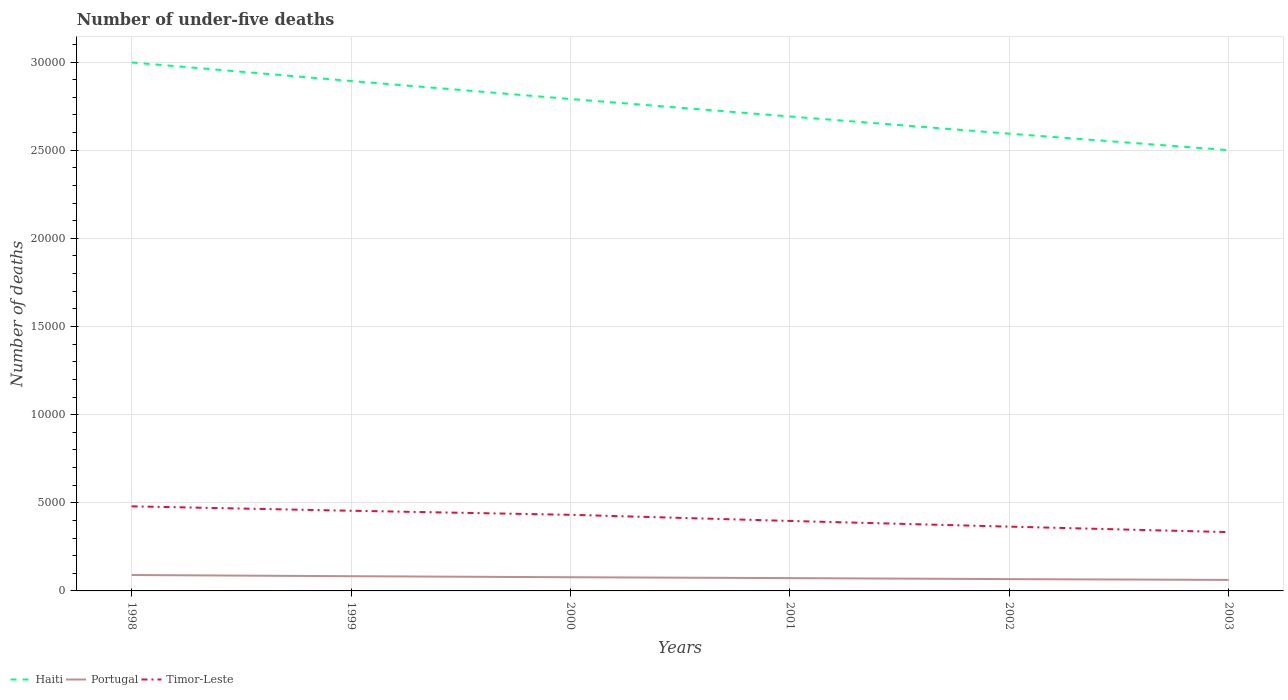How many different coloured lines are there?
Ensure brevity in your answer.  3. Does the line corresponding to Timor-Leste intersect with the line corresponding to Haiti?
Give a very brief answer. No. Across all years, what is the maximum number of under-five deaths in Timor-Leste?
Ensure brevity in your answer.  3336. What is the total number of under-five deaths in Haiti in the graph?
Make the answer very short. 4974. What is the difference between the highest and the second highest number of under-five deaths in Haiti?
Offer a terse response. 4974. What is the difference between the highest and the lowest number of under-five deaths in Haiti?
Offer a terse response. 3. How many lines are there?
Provide a succinct answer. 3. How many legend labels are there?
Give a very brief answer. 3. How are the legend labels stacked?
Give a very brief answer. Horizontal. What is the title of the graph?
Your answer should be very brief. Number of under-five deaths. Does "Kiribati" appear as one of the legend labels in the graph?
Make the answer very short. No. What is the label or title of the X-axis?
Your answer should be compact. Years. What is the label or title of the Y-axis?
Your answer should be very brief. Number of deaths. What is the Number of deaths of Haiti in 1998?
Give a very brief answer. 3.00e+04. What is the Number of deaths of Portugal in 1998?
Your response must be concise. 902. What is the Number of deaths of Timor-Leste in 1998?
Offer a terse response. 4799. What is the Number of deaths of Haiti in 1999?
Offer a terse response. 2.89e+04. What is the Number of deaths in Portugal in 1999?
Offer a very short reply. 835. What is the Number of deaths of Timor-Leste in 1999?
Keep it short and to the point. 4548. What is the Number of deaths of Haiti in 2000?
Keep it short and to the point. 2.79e+04. What is the Number of deaths in Portugal in 2000?
Your response must be concise. 776. What is the Number of deaths in Timor-Leste in 2000?
Your response must be concise. 4318. What is the Number of deaths of Haiti in 2001?
Provide a short and direct response. 2.69e+04. What is the Number of deaths in Portugal in 2001?
Provide a succinct answer. 727. What is the Number of deaths in Timor-Leste in 2001?
Provide a short and direct response. 3970. What is the Number of deaths of Haiti in 2002?
Make the answer very short. 2.59e+04. What is the Number of deaths in Portugal in 2002?
Your answer should be compact. 670. What is the Number of deaths in Timor-Leste in 2002?
Your response must be concise. 3647. What is the Number of deaths of Haiti in 2003?
Ensure brevity in your answer.  2.50e+04. What is the Number of deaths of Portugal in 2003?
Your answer should be very brief. 625. What is the Number of deaths of Timor-Leste in 2003?
Your answer should be compact. 3336. Across all years, what is the maximum Number of deaths of Haiti?
Give a very brief answer. 3.00e+04. Across all years, what is the maximum Number of deaths of Portugal?
Make the answer very short. 902. Across all years, what is the maximum Number of deaths of Timor-Leste?
Your response must be concise. 4799. Across all years, what is the minimum Number of deaths in Haiti?
Offer a very short reply. 2.50e+04. Across all years, what is the minimum Number of deaths of Portugal?
Provide a short and direct response. 625. Across all years, what is the minimum Number of deaths of Timor-Leste?
Keep it short and to the point. 3336. What is the total Number of deaths of Haiti in the graph?
Make the answer very short. 1.65e+05. What is the total Number of deaths of Portugal in the graph?
Provide a short and direct response. 4535. What is the total Number of deaths in Timor-Leste in the graph?
Give a very brief answer. 2.46e+04. What is the difference between the Number of deaths of Haiti in 1998 and that in 1999?
Your response must be concise. 1051. What is the difference between the Number of deaths in Portugal in 1998 and that in 1999?
Your answer should be very brief. 67. What is the difference between the Number of deaths in Timor-Leste in 1998 and that in 1999?
Keep it short and to the point. 251. What is the difference between the Number of deaths in Haiti in 1998 and that in 2000?
Your answer should be very brief. 2073. What is the difference between the Number of deaths of Portugal in 1998 and that in 2000?
Ensure brevity in your answer.  126. What is the difference between the Number of deaths in Timor-Leste in 1998 and that in 2000?
Ensure brevity in your answer.  481. What is the difference between the Number of deaths of Haiti in 1998 and that in 2001?
Give a very brief answer. 3064. What is the difference between the Number of deaths of Portugal in 1998 and that in 2001?
Offer a very short reply. 175. What is the difference between the Number of deaths of Timor-Leste in 1998 and that in 2001?
Ensure brevity in your answer.  829. What is the difference between the Number of deaths in Haiti in 1998 and that in 2002?
Provide a succinct answer. 4040. What is the difference between the Number of deaths in Portugal in 1998 and that in 2002?
Your answer should be compact. 232. What is the difference between the Number of deaths in Timor-Leste in 1998 and that in 2002?
Provide a succinct answer. 1152. What is the difference between the Number of deaths in Haiti in 1998 and that in 2003?
Ensure brevity in your answer.  4974. What is the difference between the Number of deaths in Portugal in 1998 and that in 2003?
Offer a very short reply. 277. What is the difference between the Number of deaths in Timor-Leste in 1998 and that in 2003?
Offer a terse response. 1463. What is the difference between the Number of deaths in Haiti in 1999 and that in 2000?
Provide a short and direct response. 1022. What is the difference between the Number of deaths of Portugal in 1999 and that in 2000?
Keep it short and to the point. 59. What is the difference between the Number of deaths of Timor-Leste in 1999 and that in 2000?
Your answer should be very brief. 230. What is the difference between the Number of deaths of Haiti in 1999 and that in 2001?
Offer a terse response. 2013. What is the difference between the Number of deaths of Portugal in 1999 and that in 2001?
Provide a short and direct response. 108. What is the difference between the Number of deaths of Timor-Leste in 1999 and that in 2001?
Offer a very short reply. 578. What is the difference between the Number of deaths in Haiti in 1999 and that in 2002?
Your response must be concise. 2989. What is the difference between the Number of deaths of Portugal in 1999 and that in 2002?
Ensure brevity in your answer.  165. What is the difference between the Number of deaths in Timor-Leste in 1999 and that in 2002?
Give a very brief answer. 901. What is the difference between the Number of deaths of Haiti in 1999 and that in 2003?
Your response must be concise. 3923. What is the difference between the Number of deaths in Portugal in 1999 and that in 2003?
Your answer should be very brief. 210. What is the difference between the Number of deaths of Timor-Leste in 1999 and that in 2003?
Your response must be concise. 1212. What is the difference between the Number of deaths in Haiti in 2000 and that in 2001?
Ensure brevity in your answer.  991. What is the difference between the Number of deaths in Portugal in 2000 and that in 2001?
Offer a terse response. 49. What is the difference between the Number of deaths of Timor-Leste in 2000 and that in 2001?
Provide a succinct answer. 348. What is the difference between the Number of deaths in Haiti in 2000 and that in 2002?
Ensure brevity in your answer.  1967. What is the difference between the Number of deaths of Portugal in 2000 and that in 2002?
Provide a succinct answer. 106. What is the difference between the Number of deaths of Timor-Leste in 2000 and that in 2002?
Your response must be concise. 671. What is the difference between the Number of deaths in Haiti in 2000 and that in 2003?
Provide a succinct answer. 2901. What is the difference between the Number of deaths in Portugal in 2000 and that in 2003?
Give a very brief answer. 151. What is the difference between the Number of deaths of Timor-Leste in 2000 and that in 2003?
Your response must be concise. 982. What is the difference between the Number of deaths in Haiti in 2001 and that in 2002?
Provide a succinct answer. 976. What is the difference between the Number of deaths of Portugal in 2001 and that in 2002?
Keep it short and to the point. 57. What is the difference between the Number of deaths in Timor-Leste in 2001 and that in 2002?
Provide a succinct answer. 323. What is the difference between the Number of deaths of Haiti in 2001 and that in 2003?
Your response must be concise. 1910. What is the difference between the Number of deaths in Portugal in 2001 and that in 2003?
Ensure brevity in your answer.  102. What is the difference between the Number of deaths in Timor-Leste in 2001 and that in 2003?
Make the answer very short. 634. What is the difference between the Number of deaths in Haiti in 2002 and that in 2003?
Make the answer very short. 934. What is the difference between the Number of deaths in Timor-Leste in 2002 and that in 2003?
Offer a very short reply. 311. What is the difference between the Number of deaths in Haiti in 1998 and the Number of deaths in Portugal in 1999?
Offer a terse response. 2.91e+04. What is the difference between the Number of deaths in Haiti in 1998 and the Number of deaths in Timor-Leste in 1999?
Your response must be concise. 2.54e+04. What is the difference between the Number of deaths of Portugal in 1998 and the Number of deaths of Timor-Leste in 1999?
Offer a very short reply. -3646. What is the difference between the Number of deaths of Haiti in 1998 and the Number of deaths of Portugal in 2000?
Provide a short and direct response. 2.92e+04. What is the difference between the Number of deaths in Haiti in 1998 and the Number of deaths in Timor-Leste in 2000?
Make the answer very short. 2.57e+04. What is the difference between the Number of deaths of Portugal in 1998 and the Number of deaths of Timor-Leste in 2000?
Offer a very short reply. -3416. What is the difference between the Number of deaths of Haiti in 1998 and the Number of deaths of Portugal in 2001?
Your answer should be very brief. 2.93e+04. What is the difference between the Number of deaths in Haiti in 1998 and the Number of deaths in Timor-Leste in 2001?
Your answer should be very brief. 2.60e+04. What is the difference between the Number of deaths in Portugal in 1998 and the Number of deaths in Timor-Leste in 2001?
Your answer should be compact. -3068. What is the difference between the Number of deaths in Haiti in 1998 and the Number of deaths in Portugal in 2002?
Ensure brevity in your answer.  2.93e+04. What is the difference between the Number of deaths of Haiti in 1998 and the Number of deaths of Timor-Leste in 2002?
Give a very brief answer. 2.63e+04. What is the difference between the Number of deaths in Portugal in 1998 and the Number of deaths in Timor-Leste in 2002?
Offer a terse response. -2745. What is the difference between the Number of deaths in Haiti in 1998 and the Number of deaths in Portugal in 2003?
Provide a short and direct response. 2.94e+04. What is the difference between the Number of deaths of Haiti in 1998 and the Number of deaths of Timor-Leste in 2003?
Provide a succinct answer. 2.66e+04. What is the difference between the Number of deaths of Portugal in 1998 and the Number of deaths of Timor-Leste in 2003?
Provide a succinct answer. -2434. What is the difference between the Number of deaths in Haiti in 1999 and the Number of deaths in Portugal in 2000?
Offer a terse response. 2.82e+04. What is the difference between the Number of deaths of Haiti in 1999 and the Number of deaths of Timor-Leste in 2000?
Keep it short and to the point. 2.46e+04. What is the difference between the Number of deaths of Portugal in 1999 and the Number of deaths of Timor-Leste in 2000?
Your response must be concise. -3483. What is the difference between the Number of deaths in Haiti in 1999 and the Number of deaths in Portugal in 2001?
Ensure brevity in your answer.  2.82e+04. What is the difference between the Number of deaths in Haiti in 1999 and the Number of deaths in Timor-Leste in 2001?
Offer a terse response. 2.50e+04. What is the difference between the Number of deaths of Portugal in 1999 and the Number of deaths of Timor-Leste in 2001?
Offer a terse response. -3135. What is the difference between the Number of deaths in Haiti in 1999 and the Number of deaths in Portugal in 2002?
Make the answer very short. 2.83e+04. What is the difference between the Number of deaths of Haiti in 1999 and the Number of deaths of Timor-Leste in 2002?
Make the answer very short. 2.53e+04. What is the difference between the Number of deaths of Portugal in 1999 and the Number of deaths of Timor-Leste in 2002?
Ensure brevity in your answer.  -2812. What is the difference between the Number of deaths of Haiti in 1999 and the Number of deaths of Portugal in 2003?
Your answer should be compact. 2.83e+04. What is the difference between the Number of deaths of Haiti in 1999 and the Number of deaths of Timor-Leste in 2003?
Provide a short and direct response. 2.56e+04. What is the difference between the Number of deaths in Portugal in 1999 and the Number of deaths in Timor-Leste in 2003?
Make the answer very short. -2501. What is the difference between the Number of deaths in Haiti in 2000 and the Number of deaths in Portugal in 2001?
Provide a short and direct response. 2.72e+04. What is the difference between the Number of deaths of Haiti in 2000 and the Number of deaths of Timor-Leste in 2001?
Give a very brief answer. 2.39e+04. What is the difference between the Number of deaths in Portugal in 2000 and the Number of deaths in Timor-Leste in 2001?
Your response must be concise. -3194. What is the difference between the Number of deaths in Haiti in 2000 and the Number of deaths in Portugal in 2002?
Ensure brevity in your answer.  2.72e+04. What is the difference between the Number of deaths of Haiti in 2000 and the Number of deaths of Timor-Leste in 2002?
Offer a very short reply. 2.43e+04. What is the difference between the Number of deaths of Portugal in 2000 and the Number of deaths of Timor-Leste in 2002?
Make the answer very short. -2871. What is the difference between the Number of deaths of Haiti in 2000 and the Number of deaths of Portugal in 2003?
Offer a terse response. 2.73e+04. What is the difference between the Number of deaths of Haiti in 2000 and the Number of deaths of Timor-Leste in 2003?
Your answer should be compact. 2.46e+04. What is the difference between the Number of deaths of Portugal in 2000 and the Number of deaths of Timor-Leste in 2003?
Your answer should be compact. -2560. What is the difference between the Number of deaths of Haiti in 2001 and the Number of deaths of Portugal in 2002?
Your answer should be compact. 2.62e+04. What is the difference between the Number of deaths of Haiti in 2001 and the Number of deaths of Timor-Leste in 2002?
Offer a terse response. 2.33e+04. What is the difference between the Number of deaths in Portugal in 2001 and the Number of deaths in Timor-Leste in 2002?
Provide a succinct answer. -2920. What is the difference between the Number of deaths of Haiti in 2001 and the Number of deaths of Portugal in 2003?
Make the answer very short. 2.63e+04. What is the difference between the Number of deaths of Haiti in 2001 and the Number of deaths of Timor-Leste in 2003?
Provide a succinct answer. 2.36e+04. What is the difference between the Number of deaths in Portugal in 2001 and the Number of deaths in Timor-Leste in 2003?
Provide a succinct answer. -2609. What is the difference between the Number of deaths of Haiti in 2002 and the Number of deaths of Portugal in 2003?
Give a very brief answer. 2.53e+04. What is the difference between the Number of deaths of Haiti in 2002 and the Number of deaths of Timor-Leste in 2003?
Offer a terse response. 2.26e+04. What is the difference between the Number of deaths of Portugal in 2002 and the Number of deaths of Timor-Leste in 2003?
Provide a short and direct response. -2666. What is the average Number of deaths of Haiti per year?
Give a very brief answer. 2.74e+04. What is the average Number of deaths in Portugal per year?
Provide a short and direct response. 755.83. What is the average Number of deaths in Timor-Leste per year?
Give a very brief answer. 4103. In the year 1998, what is the difference between the Number of deaths in Haiti and Number of deaths in Portugal?
Give a very brief answer. 2.91e+04. In the year 1998, what is the difference between the Number of deaths of Haiti and Number of deaths of Timor-Leste?
Provide a short and direct response. 2.52e+04. In the year 1998, what is the difference between the Number of deaths of Portugal and Number of deaths of Timor-Leste?
Offer a terse response. -3897. In the year 1999, what is the difference between the Number of deaths of Haiti and Number of deaths of Portugal?
Make the answer very short. 2.81e+04. In the year 1999, what is the difference between the Number of deaths of Haiti and Number of deaths of Timor-Leste?
Offer a very short reply. 2.44e+04. In the year 1999, what is the difference between the Number of deaths in Portugal and Number of deaths in Timor-Leste?
Your answer should be very brief. -3713. In the year 2000, what is the difference between the Number of deaths of Haiti and Number of deaths of Portugal?
Offer a very short reply. 2.71e+04. In the year 2000, what is the difference between the Number of deaths in Haiti and Number of deaths in Timor-Leste?
Your answer should be very brief. 2.36e+04. In the year 2000, what is the difference between the Number of deaths of Portugal and Number of deaths of Timor-Leste?
Ensure brevity in your answer.  -3542. In the year 2001, what is the difference between the Number of deaths of Haiti and Number of deaths of Portugal?
Your answer should be very brief. 2.62e+04. In the year 2001, what is the difference between the Number of deaths of Haiti and Number of deaths of Timor-Leste?
Offer a very short reply. 2.29e+04. In the year 2001, what is the difference between the Number of deaths in Portugal and Number of deaths in Timor-Leste?
Your response must be concise. -3243. In the year 2002, what is the difference between the Number of deaths of Haiti and Number of deaths of Portugal?
Ensure brevity in your answer.  2.53e+04. In the year 2002, what is the difference between the Number of deaths of Haiti and Number of deaths of Timor-Leste?
Offer a terse response. 2.23e+04. In the year 2002, what is the difference between the Number of deaths of Portugal and Number of deaths of Timor-Leste?
Offer a very short reply. -2977. In the year 2003, what is the difference between the Number of deaths of Haiti and Number of deaths of Portugal?
Keep it short and to the point. 2.44e+04. In the year 2003, what is the difference between the Number of deaths of Haiti and Number of deaths of Timor-Leste?
Offer a very short reply. 2.17e+04. In the year 2003, what is the difference between the Number of deaths in Portugal and Number of deaths in Timor-Leste?
Give a very brief answer. -2711. What is the ratio of the Number of deaths in Haiti in 1998 to that in 1999?
Keep it short and to the point. 1.04. What is the ratio of the Number of deaths in Portugal in 1998 to that in 1999?
Your answer should be compact. 1.08. What is the ratio of the Number of deaths of Timor-Leste in 1998 to that in 1999?
Provide a short and direct response. 1.06. What is the ratio of the Number of deaths in Haiti in 1998 to that in 2000?
Offer a terse response. 1.07. What is the ratio of the Number of deaths of Portugal in 1998 to that in 2000?
Offer a terse response. 1.16. What is the ratio of the Number of deaths of Timor-Leste in 1998 to that in 2000?
Give a very brief answer. 1.11. What is the ratio of the Number of deaths in Haiti in 1998 to that in 2001?
Make the answer very short. 1.11. What is the ratio of the Number of deaths in Portugal in 1998 to that in 2001?
Make the answer very short. 1.24. What is the ratio of the Number of deaths of Timor-Leste in 1998 to that in 2001?
Your answer should be very brief. 1.21. What is the ratio of the Number of deaths of Haiti in 1998 to that in 2002?
Your answer should be very brief. 1.16. What is the ratio of the Number of deaths of Portugal in 1998 to that in 2002?
Your answer should be compact. 1.35. What is the ratio of the Number of deaths in Timor-Leste in 1998 to that in 2002?
Your answer should be compact. 1.32. What is the ratio of the Number of deaths in Haiti in 1998 to that in 2003?
Your answer should be compact. 1.2. What is the ratio of the Number of deaths of Portugal in 1998 to that in 2003?
Your answer should be compact. 1.44. What is the ratio of the Number of deaths in Timor-Leste in 1998 to that in 2003?
Your response must be concise. 1.44. What is the ratio of the Number of deaths in Haiti in 1999 to that in 2000?
Your response must be concise. 1.04. What is the ratio of the Number of deaths in Portugal in 1999 to that in 2000?
Make the answer very short. 1.08. What is the ratio of the Number of deaths of Timor-Leste in 1999 to that in 2000?
Your response must be concise. 1.05. What is the ratio of the Number of deaths of Haiti in 1999 to that in 2001?
Ensure brevity in your answer.  1.07. What is the ratio of the Number of deaths in Portugal in 1999 to that in 2001?
Your answer should be compact. 1.15. What is the ratio of the Number of deaths of Timor-Leste in 1999 to that in 2001?
Offer a terse response. 1.15. What is the ratio of the Number of deaths in Haiti in 1999 to that in 2002?
Ensure brevity in your answer.  1.12. What is the ratio of the Number of deaths in Portugal in 1999 to that in 2002?
Your answer should be very brief. 1.25. What is the ratio of the Number of deaths in Timor-Leste in 1999 to that in 2002?
Give a very brief answer. 1.25. What is the ratio of the Number of deaths of Haiti in 1999 to that in 2003?
Keep it short and to the point. 1.16. What is the ratio of the Number of deaths of Portugal in 1999 to that in 2003?
Offer a very short reply. 1.34. What is the ratio of the Number of deaths in Timor-Leste in 1999 to that in 2003?
Make the answer very short. 1.36. What is the ratio of the Number of deaths in Haiti in 2000 to that in 2001?
Provide a succinct answer. 1.04. What is the ratio of the Number of deaths of Portugal in 2000 to that in 2001?
Your answer should be compact. 1.07. What is the ratio of the Number of deaths of Timor-Leste in 2000 to that in 2001?
Give a very brief answer. 1.09. What is the ratio of the Number of deaths of Haiti in 2000 to that in 2002?
Provide a succinct answer. 1.08. What is the ratio of the Number of deaths in Portugal in 2000 to that in 2002?
Ensure brevity in your answer.  1.16. What is the ratio of the Number of deaths of Timor-Leste in 2000 to that in 2002?
Your response must be concise. 1.18. What is the ratio of the Number of deaths in Haiti in 2000 to that in 2003?
Offer a very short reply. 1.12. What is the ratio of the Number of deaths in Portugal in 2000 to that in 2003?
Your response must be concise. 1.24. What is the ratio of the Number of deaths of Timor-Leste in 2000 to that in 2003?
Ensure brevity in your answer.  1.29. What is the ratio of the Number of deaths in Haiti in 2001 to that in 2002?
Give a very brief answer. 1.04. What is the ratio of the Number of deaths in Portugal in 2001 to that in 2002?
Offer a terse response. 1.09. What is the ratio of the Number of deaths in Timor-Leste in 2001 to that in 2002?
Your answer should be compact. 1.09. What is the ratio of the Number of deaths of Haiti in 2001 to that in 2003?
Provide a succinct answer. 1.08. What is the ratio of the Number of deaths in Portugal in 2001 to that in 2003?
Make the answer very short. 1.16. What is the ratio of the Number of deaths in Timor-Leste in 2001 to that in 2003?
Give a very brief answer. 1.19. What is the ratio of the Number of deaths in Haiti in 2002 to that in 2003?
Provide a succinct answer. 1.04. What is the ratio of the Number of deaths in Portugal in 2002 to that in 2003?
Your answer should be compact. 1.07. What is the ratio of the Number of deaths of Timor-Leste in 2002 to that in 2003?
Provide a succinct answer. 1.09. What is the difference between the highest and the second highest Number of deaths in Haiti?
Your answer should be compact. 1051. What is the difference between the highest and the second highest Number of deaths in Portugal?
Your answer should be compact. 67. What is the difference between the highest and the second highest Number of deaths in Timor-Leste?
Your answer should be very brief. 251. What is the difference between the highest and the lowest Number of deaths of Haiti?
Provide a short and direct response. 4974. What is the difference between the highest and the lowest Number of deaths in Portugal?
Ensure brevity in your answer.  277. What is the difference between the highest and the lowest Number of deaths of Timor-Leste?
Provide a short and direct response. 1463. 